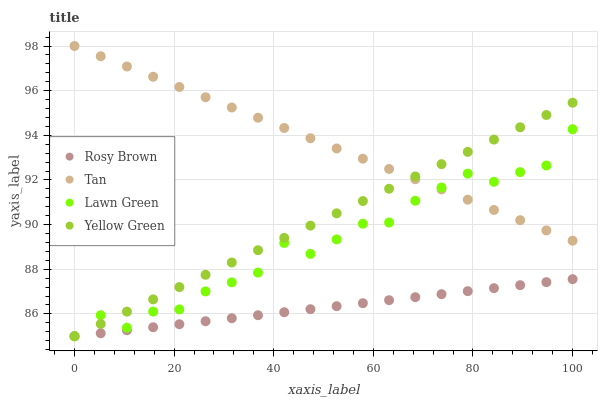Does Rosy Brown have the minimum area under the curve?
Answer yes or no. Yes. Does Tan have the maximum area under the curve?
Answer yes or no. Yes. Does Tan have the minimum area under the curve?
Answer yes or no. No. Does Rosy Brown have the maximum area under the curve?
Answer yes or no. No. Is Rosy Brown the smoothest?
Answer yes or no. Yes. Is Lawn Green the roughest?
Answer yes or no. Yes. Is Tan the smoothest?
Answer yes or no. No. Is Tan the roughest?
Answer yes or no. No. Does Lawn Green have the lowest value?
Answer yes or no. Yes. Does Tan have the lowest value?
Answer yes or no. No. Does Tan have the highest value?
Answer yes or no. Yes. Does Rosy Brown have the highest value?
Answer yes or no. No. Is Rosy Brown less than Tan?
Answer yes or no. Yes. Is Tan greater than Rosy Brown?
Answer yes or no. Yes. Does Yellow Green intersect Lawn Green?
Answer yes or no. Yes. Is Yellow Green less than Lawn Green?
Answer yes or no. No. Is Yellow Green greater than Lawn Green?
Answer yes or no. No. Does Rosy Brown intersect Tan?
Answer yes or no. No. 